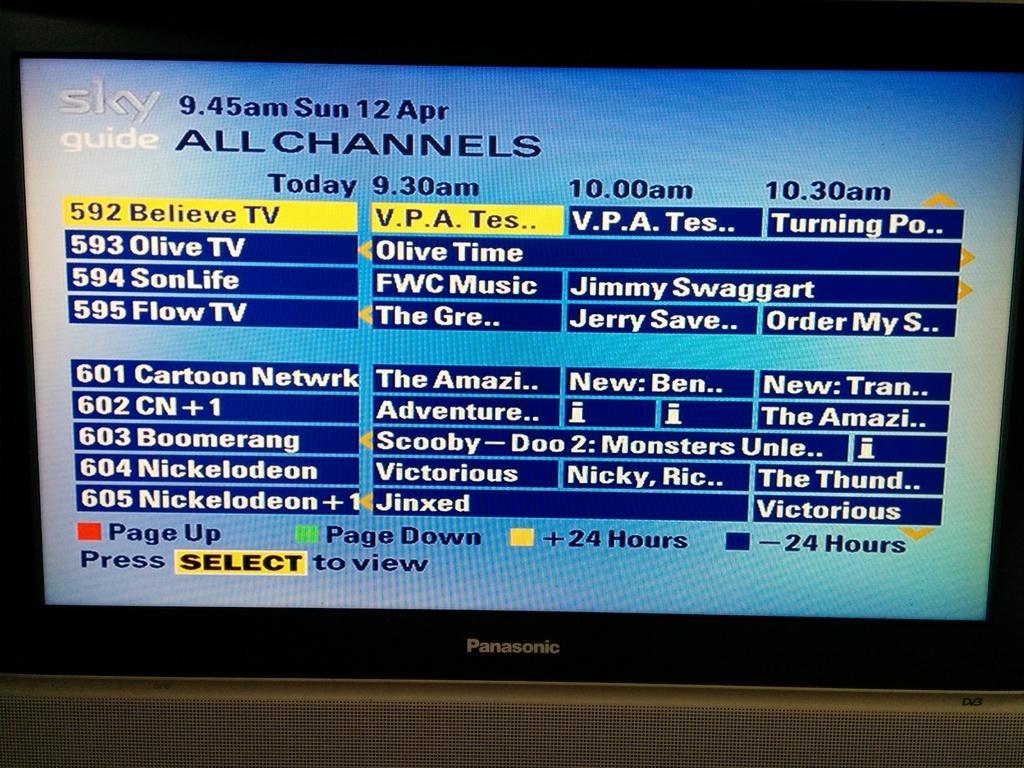In one or two sentences, can you explain what this image depicts? In this image we can see a television with some text on the screen. 